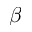<formula> <loc_0><loc_0><loc_500><loc_500>\beta</formula> 